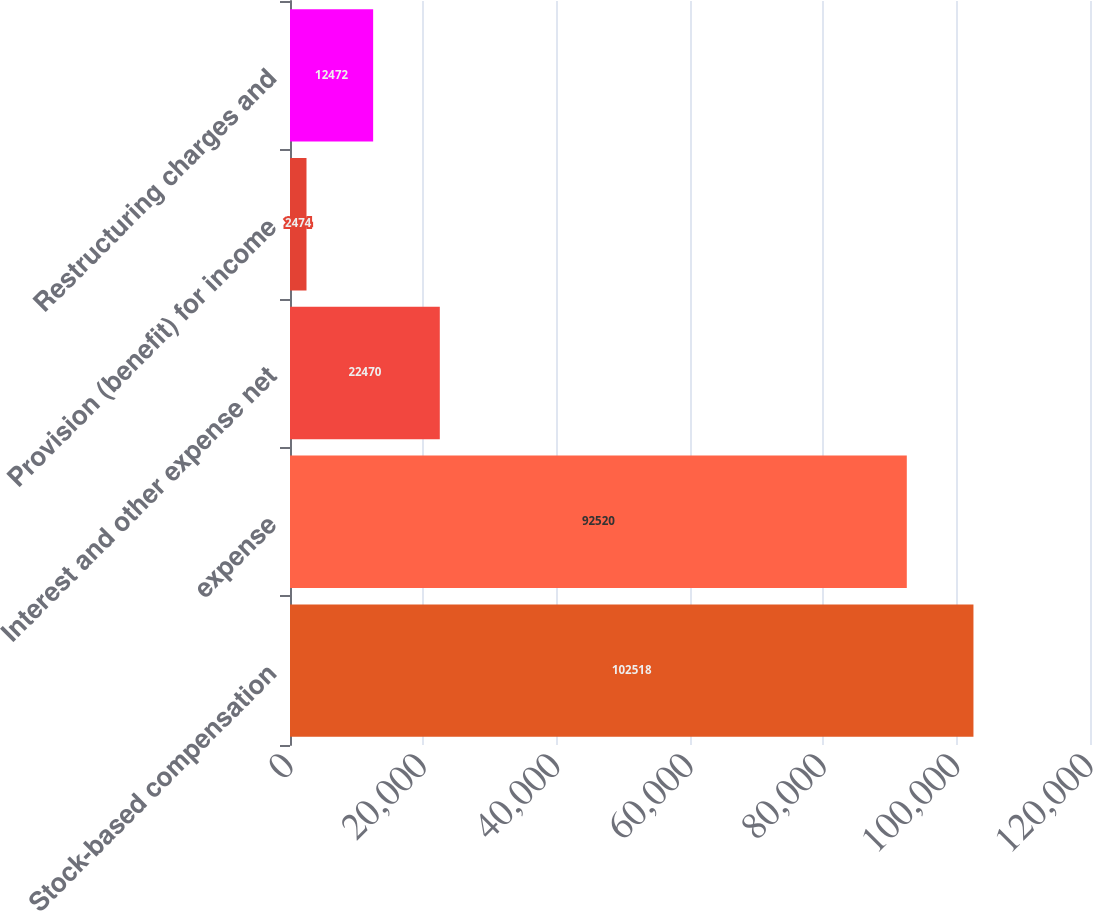<chart> <loc_0><loc_0><loc_500><loc_500><bar_chart><fcel>Stock-based compensation<fcel>expense<fcel>Interest and other expense net<fcel>Provision (benefit) for income<fcel>Restructuring charges and<nl><fcel>102518<fcel>92520<fcel>22470<fcel>2474<fcel>12472<nl></chart> 